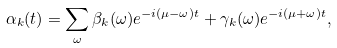Convert formula to latex. <formula><loc_0><loc_0><loc_500><loc_500>\alpha _ { k } ( t ) = \sum _ { \omega } \beta _ { k } ( \omega ) e ^ { - i ( \mu - \omega ) t } + \gamma _ { k } ( \omega ) e ^ { - i ( \mu + \omega ) t } ,</formula> 